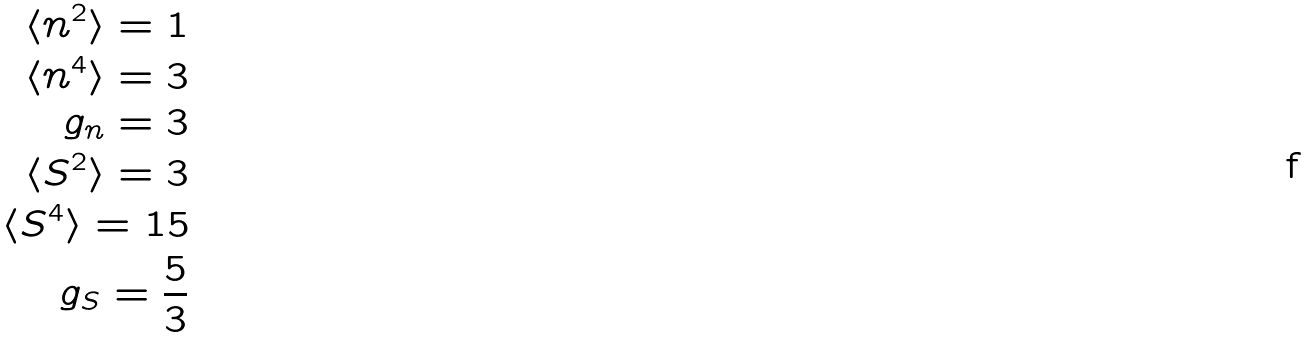Convert formula to latex. <formula><loc_0><loc_0><loc_500><loc_500>\langle n ^ { 2 } \rangle = 1 \\ \langle n ^ { 4 } \rangle = 3 \\ g _ { n } = 3 \\ \langle S ^ { 2 } \rangle = 3 \\ \langle S ^ { 4 } \rangle = 1 5 \\ g _ { S } = \frac { 5 } { 3 }</formula> 